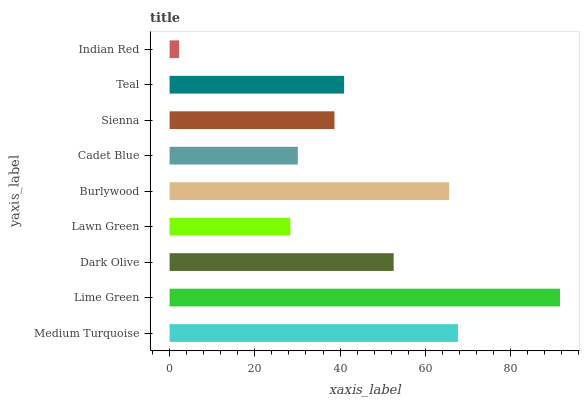Is Indian Red the minimum?
Answer yes or no. Yes. Is Lime Green the maximum?
Answer yes or no. Yes. Is Dark Olive the minimum?
Answer yes or no. No. Is Dark Olive the maximum?
Answer yes or no. No. Is Lime Green greater than Dark Olive?
Answer yes or no. Yes. Is Dark Olive less than Lime Green?
Answer yes or no. Yes. Is Dark Olive greater than Lime Green?
Answer yes or no. No. Is Lime Green less than Dark Olive?
Answer yes or no. No. Is Teal the high median?
Answer yes or no. Yes. Is Teal the low median?
Answer yes or no. Yes. Is Lawn Green the high median?
Answer yes or no. No. Is Indian Red the low median?
Answer yes or no. No. 